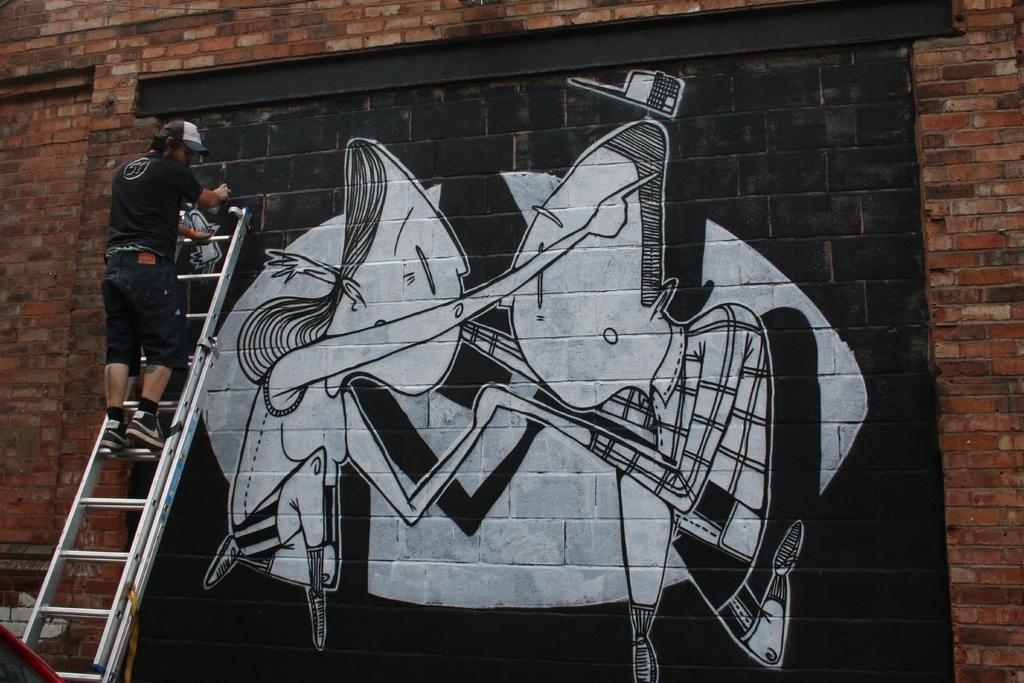What type of structure is visible in the image? There is a brick wall in the image. What is the man doing in the image? The man is standing on a ladder. What is the man doing while standing on the ladder? The man is making a painting on the wall. What type of stamp can be seen on the man's shirt in the image? There is no stamp visible on the man's shirt in the image. What type of cub is playing with the man while he paints the wall? There is no cub present in the image; the man is painting the wall alone. 